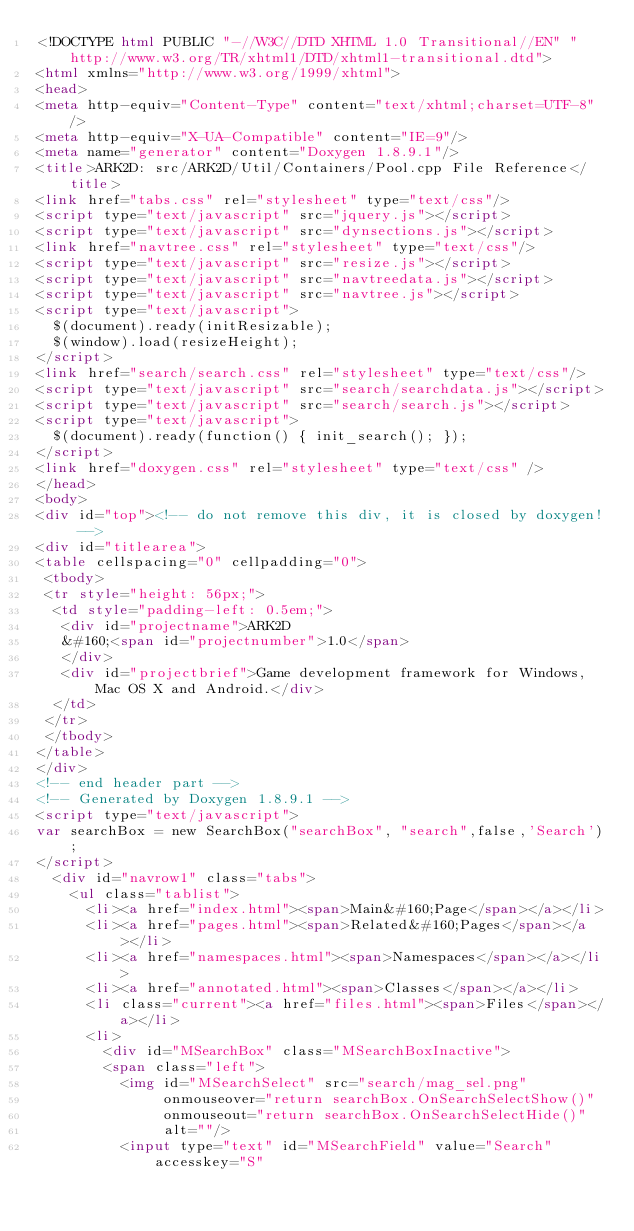<code> <loc_0><loc_0><loc_500><loc_500><_HTML_><!DOCTYPE html PUBLIC "-//W3C//DTD XHTML 1.0 Transitional//EN" "http://www.w3.org/TR/xhtml1/DTD/xhtml1-transitional.dtd">
<html xmlns="http://www.w3.org/1999/xhtml">
<head>
<meta http-equiv="Content-Type" content="text/xhtml;charset=UTF-8"/>
<meta http-equiv="X-UA-Compatible" content="IE=9"/>
<meta name="generator" content="Doxygen 1.8.9.1"/>
<title>ARK2D: src/ARK2D/Util/Containers/Pool.cpp File Reference</title>
<link href="tabs.css" rel="stylesheet" type="text/css"/>
<script type="text/javascript" src="jquery.js"></script>
<script type="text/javascript" src="dynsections.js"></script>
<link href="navtree.css" rel="stylesheet" type="text/css"/>
<script type="text/javascript" src="resize.js"></script>
<script type="text/javascript" src="navtreedata.js"></script>
<script type="text/javascript" src="navtree.js"></script>
<script type="text/javascript">
  $(document).ready(initResizable);
  $(window).load(resizeHeight);
</script>
<link href="search/search.css" rel="stylesheet" type="text/css"/>
<script type="text/javascript" src="search/searchdata.js"></script>
<script type="text/javascript" src="search/search.js"></script>
<script type="text/javascript">
  $(document).ready(function() { init_search(); });
</script>
<link href="doxygen.css" rel="stylesheet" type="text/css" />
</head>
<body>
<div id="top"><!-- do not remove this div, it is closed by doxygen! -->
<div id="titlearea">
<table cellspacing="0" cellpadding="0">
 <tbody>
 <tr style="height: 56px;">
  <td style="padding-left: 0.5em;">
   <div id="projectname">ARK2D
   &#160;<span id="projectnumber">1.0</span>
   </div>
   <div id="projectbrief">Game development framework for Windows, Mac OS X and Android.</div>
  </td>
 </tr>
 </tbody>
</table>
</div>
<!-- end header part -->
<!-- Generated by Doxygen 1.8.9.1 -->
<script type="text/javascript">
var searchBox = new SearchBox("searchBox", "search",false,'Search');
</script>
  <div id="navrow1" class="tabs">
    <ul class="tablist">
      <li><a href="index.html"><span>Main&#160;Page</span></a></li>
      <li><a href="pages.html"><span>Related&#160;Pages</span></a></li>
      <li><a href="namespaces.html"><span>Namespaces</span></a></li>
      <li><a href="annotated.html"><span>Classes</span></a></li>
      <li class="current"><a href="files.html"><span>Files</span></a></li>
      <li>
        <div id="MSearchBox" class="MSearchBoxInactive">
        <span class="left">
          <img id="MSearchSelect" src="search/mag_sel.png"
               onmouseover="return searchBox.OnSearchSelectShow()"
               onmouseout="return searchBox.OnSearchSelectHide()"
               alt=""/>
          <input type="text" id="MSearchField" value="Search" accesskey="S"</code> 